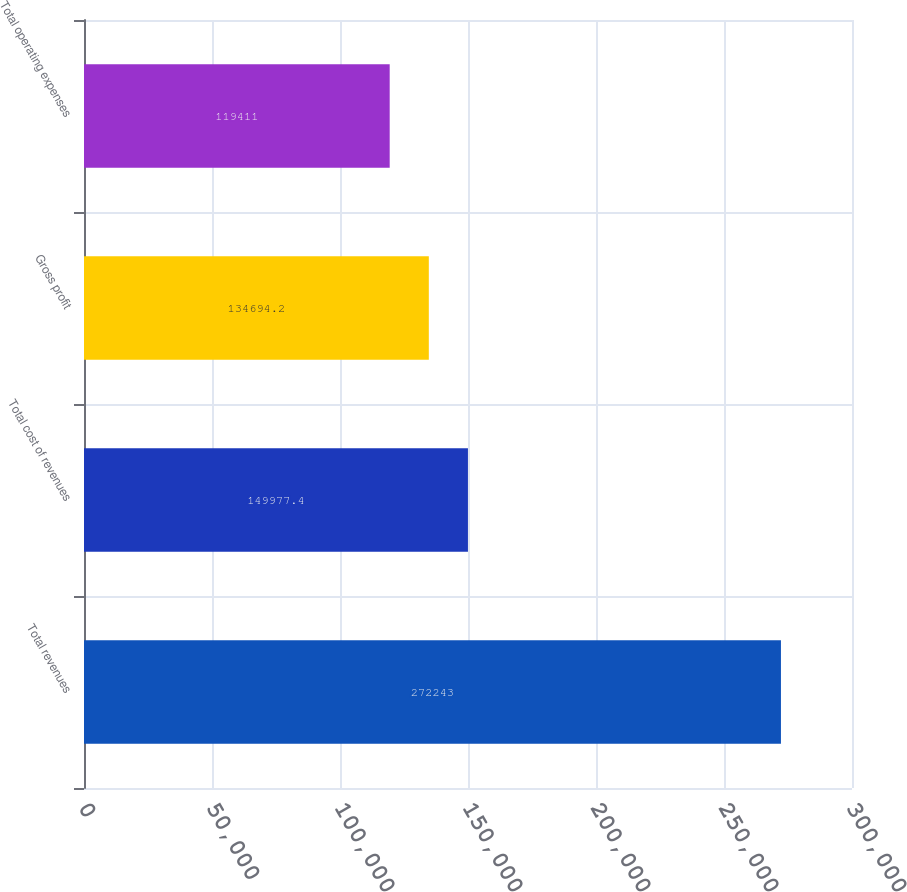Convert chart to OTSL. <chart><loc_0><loc_0><loc_500><loc_500><bar_chart><fcel>Total revenues<fcel>Total cost of revenues<fcel>Gross profit<fcel>Total operating expenses<nl><fcel>272243<fcel>149977<fcel>134694<fcel>119411<nl></chart> 